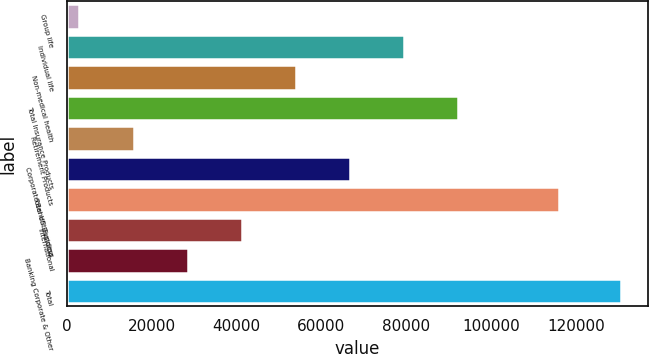Convert chart to OTSL. <chart><loc_0><loc_0><loc_500><loc_500><bar_chart><fcel>Group life<fcel>Individual life<fcel>Non-medical health<fcel>Total Insurance Products<fcel>Retirement Products<fcel>Corporate Benefit Funding<fcel>Total US Business<fcel>International<fcel>Banking Corporate & Other<fcel>Total<nl><fcel>2984<fcel>79526.6<fcel>54012.4<fcel>92283.7<fcel>15741.1<fcel>66769.5<fcel>116122<fcel>41255.3<fcel>28498.2<fcel>130555<nl></chart> 